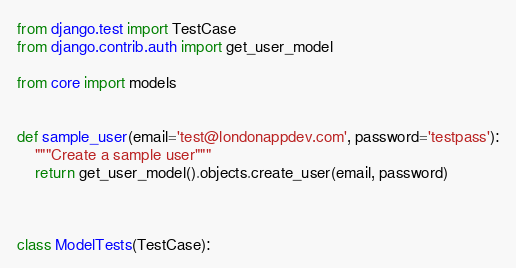Convert code to text. <code><loc_0><loc_0><loc_500><loc_500><_Python_>from django.test import TestCase
from django.contrib.auth import get_user_model

from core import models


def sample_user(email='test@londonappdev.com', password='testpass'):
    """Create a sample user"""
    return get_user_model().objects.create_user(email, password)



class ModelTests(TestCase):
</code> 